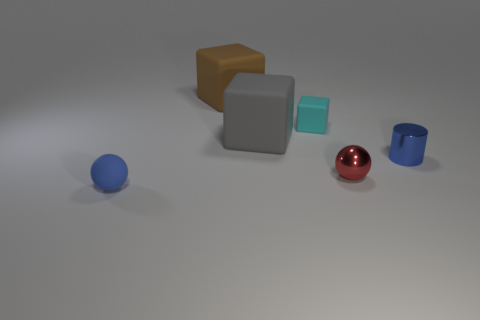The other matte thing that is the same shape as the tiny red thing is what size?
Offer a terse response. Small. How many other things are there of the same material as the small block?
Your response must be concise. 3. What material is the tiny red object?
Offer a very short reply. Metal. There is a metallic thing behind the tiny red sphere; does it have the same color as the small shiny object in front of the tiny cylinder?
Provide a succinct answer. No. Are there more blue rubber objects that are right of the blue sphere than tiny blue shiny cylinders?
Your answer should be compact. No. What number of other things are there of the same color as the small matte sphere?
Provide a succinct answer. 1. Does the sphere that is to the right of the blue rubber sphere have the same size as the big brown rubber object?
Keep it short and to the point. No. Are there any gray objects that have the same size as the blue shiny thing?
Your answer should be very brief. No. The large matte block to the right of the brown cube is what color?
Make the answer very short. Gray. What shape is the rubber object that is both behind the small blue shiny thing and in front of the cyan matte thing?
Offer a terse response. Cube. 